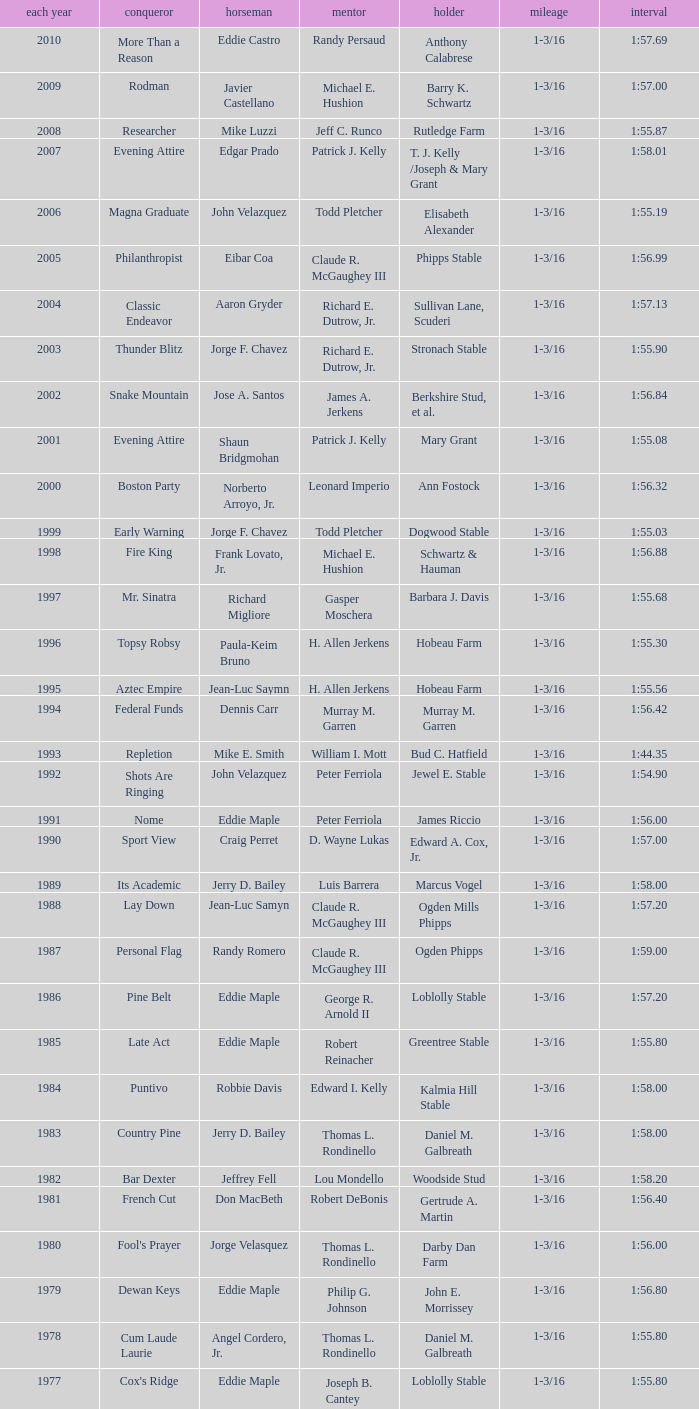Who was the jockey for the winning horse Helioptic? Paul Miller. 